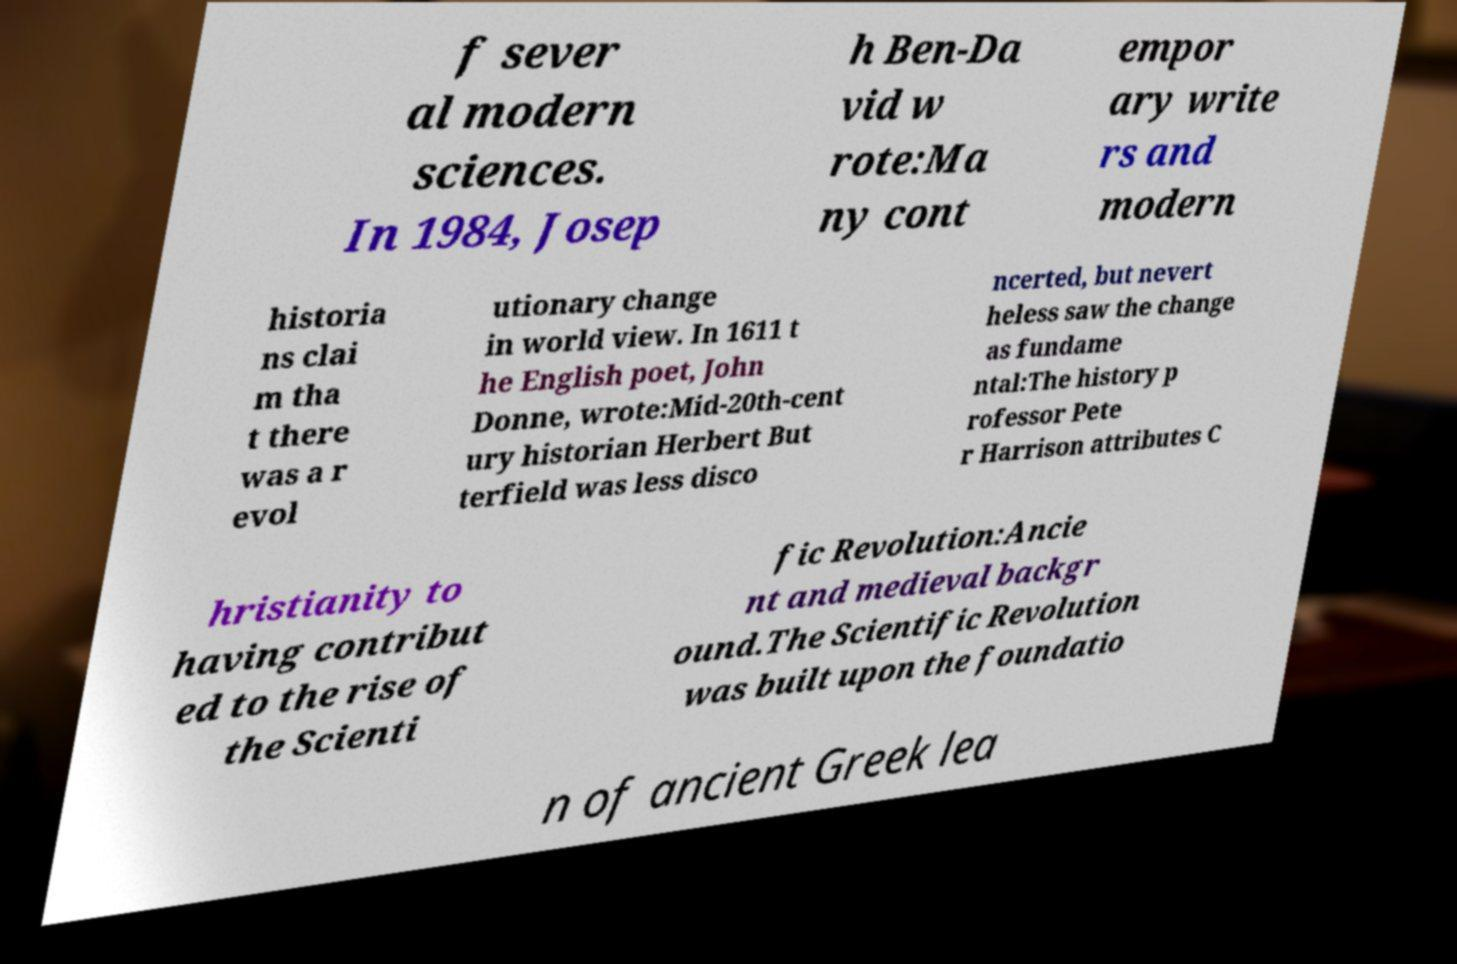There's text embedded in this image that I need extracted. Can you transcribe it verbatim? f sever al modern sciences. In 1984, Josep h Ben-Da vid w rote:Ma ny cont empor ary write rs and modern historia ns clai m tha t there was a r evol utionary change in world view. In 1611 t he English poet, John Donne, wrote:Mid-20th-cent ury historian Herbert But terfield was less disco ncerted, but nevert heless saw the change as fundame ntal:The history p rofessor Pete r Harrison attributes C hristianity to having contribut ed to the rise of the Scienti fic Revolution:Ancie nt and medieval backgr ound.The Scientific Revolution was built upon the foundatio n of ancient Greek lea 